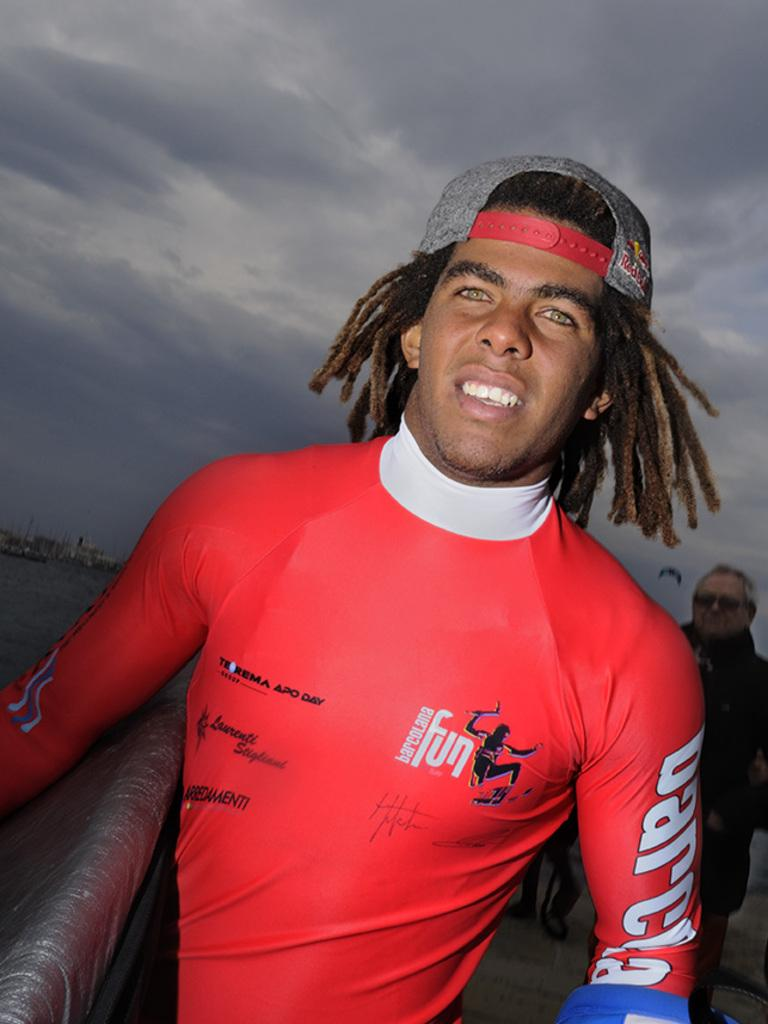<image>
Share a concise interpretation of the image provided. man with a surfboard and dreadlock hair at the beach 